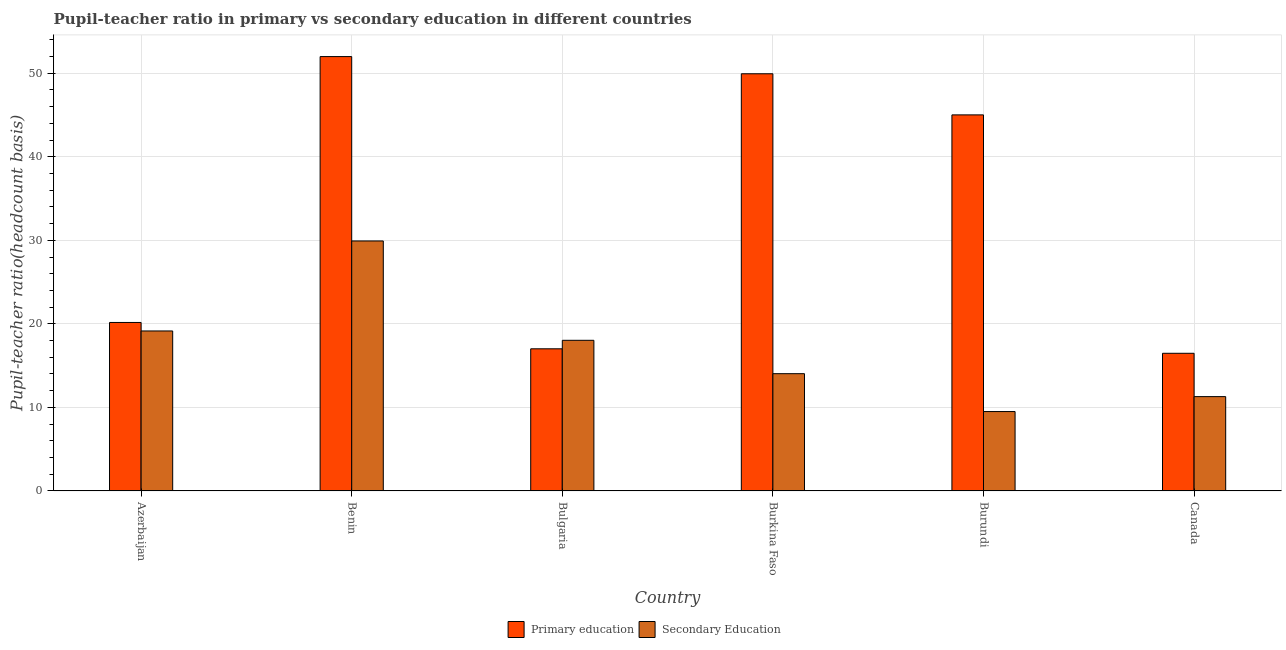How many different coloured bars are there?
Ensure brevity in your answer.  2. How many groups of bars are there?
Offer a terse response. 6. How many bars are there on the 3rd tick from the left?
Your response must be concise. 2. What is the label of the 2nd group of bars from the left?
Your answer should be compact. Benin. What is the pupil-teacher ratio in primary education in Burkina Faso?
Your response must be concise. 49.94. Across all countries, what is the maximum pupil teacher ratio on secondary education?
Ensure brevity in your answer.  29.92. Across all countries, what is the minimum pupil teacher ratio on secondary education?
Your response must be concise. 9.5. In which country was the pupil teacher ratio on secondary education maximum?
Give a very brief answer. Benin. In which country was the pupil teacher ratio on secondary education minimum?
Your response must be concise. Burundi. What is the total pupil-teacher ratio in primary education in the graph?
Offer a very short reply. 200.61. What is the difference between the pupil-teacher ratio in primary education in Bulgaria and that in Canada?
Make the answer very short. 0.54. What is the difference between the pupil teacher ratio on secondary education in Canada and the pupil-teacher ratio in primary education in Azerbaijan?
Your answer should be compact. -8.88. What is the average pupil-teacher ratio in primary education per country?
Make the answer very short. 33.44. What is the difference between the pupil teacher ratio on secondary education and pupil-teacher ratio in primary education in Burundi?
Offer a very short reply. -35.51. In how many countries, is the pupil teacher ratio on secondary education greater than 46 ?
Ensure brevity in your answer.  0. What is the ratio of the pupil teacher ratio on secondary education in Azerbaijan to that in Burundi?
Provide a short and direct response. 2.02. Is the pupil-teacher ratio in primary education in Burundi less than that in Canada?
Provide a short and direct response. No. Is the difference between the pupil-teacher ratio in primary education in Burkina Faso and Burundi greater than the difference between the pupil teacher ratio on secondary education in Burkina Faso and Burundi?
Offer a very short reply. Yes. What is the difference between the highest and the second highest pupil teacher ratio on secondary education?
Offer a terse response. 10.77. What is the difference between the highest and the lowest pupil teacher ratio on secondary education?
Your answer should be very brief. 20.42. In how many countries, is the pupil-teacher ratio in primary education greater than the average pupil-teacher ratio in primary education taken over all countries?
Give a very brief answer. 3. What does the 2nd bar from the left in Burundi represents?
Make the answer very short. Secondary Education. How many bars are there?
Your answer should be very brief. 12. Are all the bars in the graph horizontal?
Your answer should be very brief. No. How many countries are there in the graph?
Provide a succinct answer. 6. Does the graph contain any zero values?
Your answer should be compact. No. Where does the legend appear in the graph?
Make the answer very short. Bottom center. How many legend labels are there?
Offer a terse response. 2. What is the title of the graph?
Keep it short and to the point. Pupil-teacher ratio in primary vs secondary education in different countries. Does "Electricity and heat production" appear as one of the legend labels in the graph?
Offer a terse response. No. What is the label or title of the X-axis?
Your response must be concise. Country. What is the label or title of the Y-axis?
Provide a short and direct response. Pupil-teacher ratio(headcount basis). What is the Pupil-teacher ratio(headcount basis) of Primary education in Azerbaijan?
Keep it short and to the point. 20.17. What is the Pupil-teacher ratio(headcount basis) in Secondary Education in Azerbaijan?
Offer a very short reply. 19.15. What is the Pupil-teacher ratio(headcount basis) in Primary education in Benin?
Your response must be concise. 52. What is the Pupil-teacher ratio(headcount basis) of Secondary Education in Benin?
Provide a short and direct response. 29.92. What is the Pupil-teacher ratio(headcount basis) in Primary education in Bulgaria?
Make the answer very short. 17.01. What is the Pupil-teacher ratio(headcount basis) in Secondary Education in Bulgaria?
Keep it short and to the point. 18.03. What is the Pupil-teacher ratio(headcount basis) of Primary education in Burkina Faso?
Your answer should be compact. 49.94. What is the Pupil-teacher ratio(headcount basis) of Secondary Education in Burkina Faso?
Make the answer very short. 14.04. What is the Pupil-teacher ratio(headcount basis) of Primary education in Burundi?
Your answer should be compact. 45.02. What is the Pupil-teacher ratio(headcount basis) of Secondary Education in Burundi?
Provide a short and direct response. 9.5. What is the Pupil-teacher ratio(headcount basis) in Primary education in Canada?
Provide a short and direct response. 16.48. What is the Pupil-teacher ratio(headcount basis) of Secondary Education in Canada?
Make the answer very short. 11.29. Across all countries, what is the maximum Pupil-teacher ratio(headcount basis) of Primary education?
Offer a very short reply. 52. Across all countries, what is the maximum Pupil-teacher ratio(headcount basis) of Secondary Education?
Make the answer very short. 29.92. Across all countries, what is the minimum Pupil-teacher ratio(headcount basis) in Primary education?
Provide a short and direct response. 16.48. Across all countries, what is the minimum Pupil-teacher ratio(headcount basis) in Secondary Education?
Give a very brief answer. 9.5. What is the total Pupil-teacher ratio(headcount basis) in Primary education in the graph?
Your response must be concise. 200.61. What is the total Pupil-teacher ratio(headcount basis) of Secondary Education in the graph?
Your answer should be very brief. 101.94. What is the difference between the Pupil-teacher ratio(headcount basis) of Primary education in Azerbaijan and that in Benin?
Your response must be concise. -31.83. What is the difference between the Pupil-teacher ratio(headcount basis) in Secondary Education in Azerbaijan and that in Benin?
Provide a short and direct response. -10.77. What is the difference between the Pupil-teacher ratio(headcount basis) of Primary education in Azerbaijan and that in Bulgaria?
Provide a short and direct response. 3.15. What is the difference between the Pupil-teacher ratio(headcount basis) of Secondary Education in Azerbaijan and that in Bulgaria?
Your answer should be very brief. 1.12. What is the difference between the Pupil-teacher ratio(headcount basis) of Primary education in Azerbaijan and that in Burkina Faso?
Offer a very short reply. -29.77. What is the difference between the Pupil-teacher ratio(headcount basis) of Secondary Education in Azerbaijan and that in Burkina Faso?
Offer a very short reply. 5.11. What is the difference between the Pupil-teacher ratio(headcount basis) in Primary education in Azerbaijan and that in Burundi?
Your answer should be very brief. -24.85. What is the difference between the Pupil-teacher ratio(headcount basis) in Secondary Education in Azerbaijan and that in Burundi?
Your answer should be compact. 9.65. What is the difference between the Pupil-teacher ratio(headcount basis) of Primary education in Azerbaijan and that in Canada?
Provide a short and direct response. 3.69. What is the difference between the Pupil-teacher ratio(headcount basis) of Secondary Education in Azerbaijan and that in Canada?
Offer a very short reply. 7.86. What is the difference between the Pupil-teacher ratio(headcount basis) in Primary education in Benin and that in Bulgaria?
Offer a very short reply. 34.98. What is the difference between the Pupil-teacher ratio(headcount basis) in Secondary Education in Benin and that in Bulgaria?
Give a very brief answer. 11.89. What is the difference between the Pupil-teacher ratio(headcount basis) in Primary education in Benin and that in Burkina Faso?
Keep it short and to the point. 2.06. What is the difference between the Pupil-teacher ratio(headcount basis) of Secondary Education in Benin and that in Burkina Faso?
Provide a short and direct response. 15.89. What is the difference between the Pupil-teacher ratio(headcount basis) in Primary education in Benin and that in Burundi?
Your response must be concise. 6.98. What is the difference between the Pupil-teacher ratio(headcount basis) in Secondary Education in Benin and that in Burundi?
Your response must be concise. 20.42. What is the difference between the Pupil-teacher ratio(headcount basis) of Primary education in Benin and that in Canada?
Ensure brevity in your answer.  35.52. What is the difference between the Pupil-teacher ratio(headcount basis) in Secondary Education in Benin and that in Canada?
Your answer should be compact. 18.63. What is the difference between the Pupil-teacher ratio(headcount basis) of Primary education in Bulgaria and that in Burkina Faso?
Your answer should be compact. -32.92. What is the difference between the Pupil-teacher ratio(headcount basis) in Secondary Education in Bulgaria and that in Burkina Faso?
Your answer should be compact. 4. What is the difference between the Pupil-teacher ratio(headcount basis) in Primary education in Bulgaria and that in Burundi?
Your answer should be compact. -28. What is the difference between the Pupil-teacher ratio(headcount basis) in Secondary Education in Bulgaria and that in Burundi?
Your answer should be very brief. 8.53. What is the difference between the Pupil-teacher ratio(headcount basis) of Primary education in Bulgaria and that in Canada?
Offer a very short reply. 0.54. What is the difference between the Pupil-teacher ratio(headcount basis) in Secondary Education in Bulgaria and that in Canada?
Your answer should be compact. 6.74. What is the difference between the Pupil-teacher ratio(headcount basis) in Primary education in Burkina Faso and that in Burundi?
Keep it short and to the point. 4.92. What is the difference between the Pupil-teacher ratio(headcount basis) in Secondary Education in Burkina Faso and that in Burundi?
Give a very brief answer. 4.53. What is the difference between the Pupil-teacher ratio(headcount basis) of Primary education in Burkina Faso and that in Canada?
Ensure brevity in your answer.  33.46. What is the difference between the Pupil-teacher ratio(headcount basis) of Secondary Education in Burkina Faso and that in Canada?
Provide a short and direct response. 2.75. What is the difference between the Pupil-teacher ratio(headcount basis) in Primary education in Burundi and that in Canada?
Offer a terse response. 28.54. What is the difference between the Pupil-teacher ratio(headcount basis) in Secondary Education in Burundi and that in Canada?
Offer a very short reply. -1.79. What is the difference between the Pupil-teacher ratio(headcount basis) of Primary education in Azerbaijan and the Pupil-teacher ratio(headcount basis) of Secondary Education in Benin?
Provide a succinct answer. -9.76. What is the difference between the Pupil-teacher ratio(headcount basis) of Primary education in Azerbaijan and the Pupil-teacher ratio(headcount basis) of Secondary Education in Bulgaria?
Offer a very short reply. 2.13. What is the difference between the Pupil-teacher ratio(headcount basis) of Primary education in Azerbaijan and the Pupil-teacher ratio(headcount basis) of Secondary Education in Burkina Faso?
Offer a very short reply. 6.13. What is the difference between the Pupil-teacher ratio(headcount basis) in Primary education in Azerbaijan and the Pupil-teacher ratio(headcount basis) in Secondary Education in Burundi?
Provide a short and direct response. 10.66. What is the difference between the Pupil-teacher ratio(headcount basis) in Primary education in Azerbaijan and the Pupil-teacher ratio(headcount basis) in Secondary Education in Canada?
Offer a terse response. 8.88. What is the difference between the Pupil-teacher ratio(headcount basis) in Primary education in Benin and the Pupil-teacher ratio(headcount basis) in Secondary Education in Bulgaria?
Your response must be concise. 33.96. What is the difference between the Pupil-teacher ratio(headcount basis) of Primary education in Benin and the Pupil-teacher ratio(headcount basis) of Secondary Education in Burkina Faso?
Give a very brief answer. 37.96. What is the difference between the Pupil-teacher ratio(headcount basis) in Primary education in Benin and the Pupil-teacher ratio(headcount basis) in Secondary Education in Burundi?
Provide a short and direct response. 42.49. What is the difference between the Pupil-teacher ratio(headcount basis) of Primary education in Benin and the Pupil-teacher ratio(headcount basis) of Secondary Education in Canada?
Keep it short and to the point. 40.7. What is the difference between the Pupil-teacher ratio(headcount basis) in Primary education in Bulgaria and the Pupil-teacher ratio(headcount basis) in Secondary Education in Burkina Faso?
Give a very brief answer. 2.98. What is the difference between the Pupil-teacher ratio(headcount basis) in Primary education in Bulgaria and the Pupil-teacher ratio(headcount basis) in Secondary Education in Burundi?
Offer a very short reply. 7.51. What is the difference between the Pupil-teacher ratio(headcount basis) of Primary education in Bulgaria and the Pupil-teacher ratio(headcount basis) of Secondary Education in Canada?
Your answer should be very brief. 5.72. What is the difference between the Pupil-teacher ratio(headcount basis) of Primary education in Burkina Faso and the Pupil-teacher ratio(headcount basis) of Secondary Education in Burundi?
Ensure brevity in your answer.  40.44. What is the difference between the Pupil-teacher ratio(headcount basis) of Primary education in Burkina Faso and the Pupil-teacher ratio(headcount basis) of Secondary Education in Canada?
Keep it short and to the point. 38.65. What is the difference between the Pupil-teacher ratio(headcount basis) of Primary education in Burundi and the Pupil-teacher ratio(headcount basis) of Secondary Education in Canada?
Keep it short and to the point. 33.73. What is the average Pupil-teacher ratio(headcount basis) in Primary education per country?
Provide a short and direct response. 33.44. What is the average Pupil-teacher ratio(headcount basis) of Secondary Education per country?
Make the answer very short. 16.99. What is the difference between the Pupil-teacher ratio(headcount basis) in Primary education and Pupil-teacher ratio(headcount basis) in Secondary Education in Azerbaijan?
Offer a very short reply. 1.02. What is the difference between the Pupil-teacher ratio(headcount basis) in Primary education and Pupil-teacher ratio(headcount basis) in Secondary Education in Benin?
Your answer should be very brief. 22.07. What is the difference between the Pupil-teacher ratio(headcount basis) of Primary education and Pupil-teacher ratio(headcount basis) of Secondary Education in Bulgaria?
Your answer should be compact. -1.02. What is the difference between the Pupil-teacher ratio(headcount basis) of Primary education and Pupil-teacher ratio(headcount basis) of Secondary Education in Burkina Faso?
Make the answer very short. 35.9. What is the difference between the Pupil-teacher ratio(headcount basis) in Primary education and Pupil-teacher ratio(headcount basis) in Secondary Education in Burundi?
Provide a succinct answer. 35.51. What is the difference between the Pupil-teacher ratio(headcount basis) in Primary education and Pupil-teacher ratio(headcount basis) in Secondary Education in Canada?
Keep it short and to the point. 5.19. What is the ratio of the Pupil-teacher ratio(headcount basis) in Primary education in Azerbaijan to that in Benin?
Make the answer very short. 0.39. What is the ratio of the Pupil-teacher ratio(headcount basis) in Secondary Education in Azerbaijan to that in Benin?
Provide a succinct answer. 0.64. What is the ratio of the Pupil-teacher ratio(headcount basis) of Primary education in Azerbaijan to that in Bulgaria?
Provide a succinct answer. 1.19. What is the ratio of the Pupil-teacher ratio(headcount basis) of Secondary Education in Azerbaijan to that in Bulgaria?
Offer a terse response. 1.06. What is the ratio of the Pupil-teacher ratio(headcount basis) of Primary education in Azerbaijan to that in Burkina Faso?
Keep it short and to the point. 0.4. What is the ratio of the Pupil-teacher ratio(headcount basis) of Secondary Education in Azerbaijan to that in Burkina Faso?
Provide a succinct answer. 1.36. What is the ratio of the Pupil-teacher ratio(headcount basis) of Primary education in Azerbaijan to that in Burundi?
Keep it short and to the point. 0.45. What is the ratio of the Pupil-teacher ratio(headcount basis) in Secondary Education in Azerbaijan to that in Burundi?
Make the answer very short. 2.02. What is the ratio of the Pupil-teacher ratio(headcount basis) of Primary education in Azerbaijan to that in Canada?
Your answer should be compact. 1.22. What is the ratio of the Pupil-teacher ratio(headcount basis) of Secondary Education in Azerbaijan to that in Canada?
Make the answer very short. 1.7. What is the ratio of the Pupil-teacher ratio(headcount basis) in Primary education in Benin to that in Bulgaria?
Your answer should be very brief. 3.06. What is the ratio of the Pupil-teacher ratio(headcount basis) of Secondary Education in Benin to that in Bulgaria?
Provide a short and direct response. 1.66. What is the ratio of the Pupil-teacher ratio(headcount basis) in Primary education in Benin to that in Burkina Faso?
Provide a short and direct response. 1.04. What is the ratio of the Pupil-teacher ratio(headcount basis) of Secondary Education in Benin to that in Burkina Faso?
Ensure brevity in your answer.  2.13. What is the ratio of the Pupil-teacher ratio(headcount basis) of Primary education in Benin to that in Burundi?
Ensure brevity in your answer.  1.16. What is the ratio of the Pupil-teacher ratio(headcount basis) of Secondary Education in Benin to that in Burundi?
Provide a succinct answer. 3.15. What is the ratio of the Pupil-teacher ratio(headcount basis) of Primary education in Benin to that in Canada?
Ensure brevity in your answer.  3.16. What is the ratio of the Pupil-teacher ratio(headcount basis) of Secondary Education in Benin to that in Canada?
Your answer should be very brief. 2.65. What is the ratio of the Pupil-teacher ratio(headcount basis) of Primary education in Bulgaria to that in Burkina Faso?
Provide a succinct answer. 0.34. What is the ratio of the Pupil-teacher ratio(headcount basis) in Secondary Education in Bulgaria to that in Burkina Faso?
Your answer should be very brief. 1.28. What is the ratio of the Pupil-teacher ratio(headcount basis) in Primary education in Bulgaria to that in Burundi?
Make the answer very short. 0.38. What is the ratio of the Pupil-teacher ratio(headcount basis) in Secondary Education in Bulgaria to that in Burundi?
Provide a short and direct response. 1.9. What is the ratio of the Pupil-teacher ratio(headcount basis) of Primary education in Bulgaria to that in Canada?
Offer a very short reply. 1.03. What is the ratio of the Pupil-teacher ratio(headcount basis) in Secondary Education in Bulgaria to that in Canada?
Your response must be concise. 1.6. What is the ratio of the Pupil-teacher ratio(headcount basis) in Primary education in Burkina Faso to that in Burundi?
Provide a succinct answer. 1.11. What is the ratio of the Pupil-teacher ratio(headcount basis) in Secondary Education in Burkina Faso to that in Burundi?
Offer a very short reply. 1.48. What is the ratio of the Pupil-teacher ratio(headcount basis) in Primary education in Burkina Faso to that in Canada?
Provide a succinct answer. 3.03. What is the ratio of the Pupil-teacher ratio(headcount basis) in Secondary Education in Burkina Faso to that in Canada?
Provide a short and direct response. 1.24. What is the ratio of the Pupil-teacher ratio(headcount basis) in Primary education in Burundi to that in Canada?
Provide a succinct answer. 2.73. What is the ratio of the Pupil-teacher ratio(headcount basis) in Secondary Education in Burundi to that in Canada?
Offer a terse response. 0.84. What is the difference between the highest and the second highest Pupil-teacher ratio(headcount basis) in Primary education?
Keep it short and to the point. 2.06. What is the difference between the highest and the second highest Pupil-teacher ratio(headcount basis) of Secondary Education?
Ensure brevity in your answer.  10.77. What is the difference between the highest and the lowest Pupil-teacher ratio(headcount basis) in Primary education?
Provide a short and direct response. 35.52. What is the difference between the highest and the lowest Pupil-teacher ratio(headcount basis) of Secondary Education?
Ensure brevity in your answer.  20.42. 